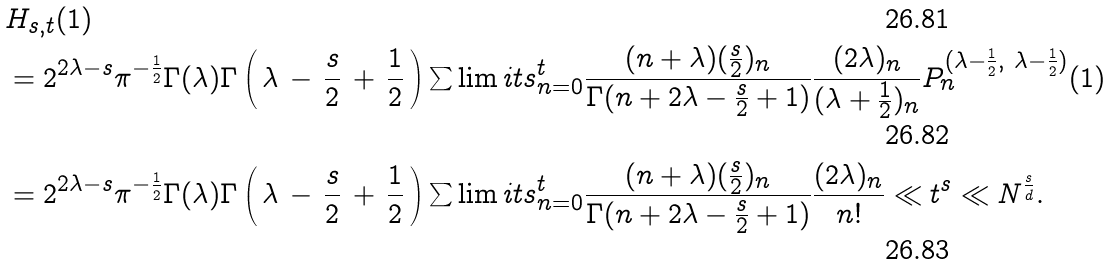<formula> <loc_0><loc_0><loc_500><loc_500>& H _ { s , t } ( 1 ) \\ & = 2 ^ { 2 \lambda - s } \pi ^ { - \frac { 1 } { 2 } } \Gamma ( \lambda ) \Gamma \left ( \, \lambda \, - \, \frac { s } { 2 } \, + \, \frac { 1 } { 2 } \, \right ) \sum \lim i t s _ { n = 0 } ^ { t } \frac { ( n + \lambda ) ( \frac { s } { 2 } ) _ { n } } { \Gamma ( n + 2 \lambda - \frac { s } { 2 } + 1 ) } \frac { ( 2 \lambda ) _ { n } } { ( \lambda + \frac { 1 } { 2 } ) _ { n } } P _ { n } ^ { ( \lambda - \frac { 1 } { 2 } , \ \lambda - \frac { 1 } { 2 } ) } ( 1 ) \\ & = 2 ^ { 2 \lambda - s } \pi ^ { - \frac { 1 } { 2 } } \Gamma ( \lambda ) \Gamma \left ( \, \lambda \, - \, \frac { s } { 2 } \, + \, \frac { 1 } { 2 } \, \right ) \sum \lim i t s _ { n = 0 } ^ { t } \frac { ( n + \lambda ) ( \frac { s } { 2 } ) _ { n } } { \Gamma ( n + 2 \lambda - \frac { s } { 2 } + 1 ) } \frac { ( 2 \lambda ) _ { n } } { n ! } \ll t ^ { s } \ll N ^ { \frac { s } { d } } .</formula> 